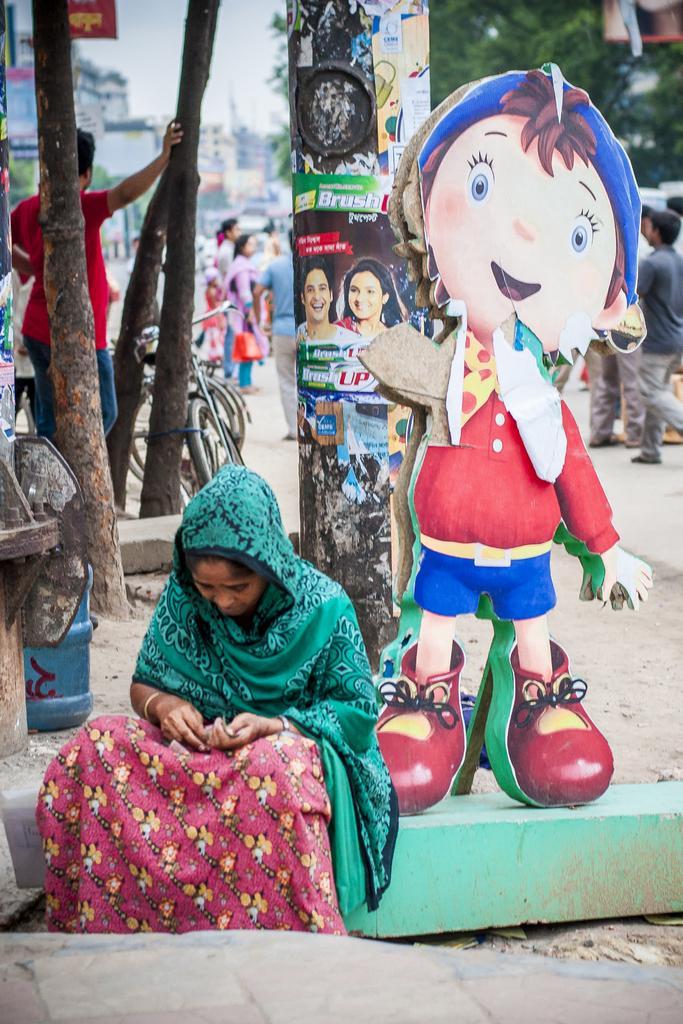Could you give a brief overview of what you see in this image? In this image there is a woman sitting on the stone. The woman is wearing the green color scarf. On the right side there is a hoarding of a man near the pole. On the left side there are trees. In the background there is a road on which there are few people walking on it. Beside the woman there is a water can on the ground. There is a man who is standing on the floor by keeping his hand on the tree. There are buildings in the background. 